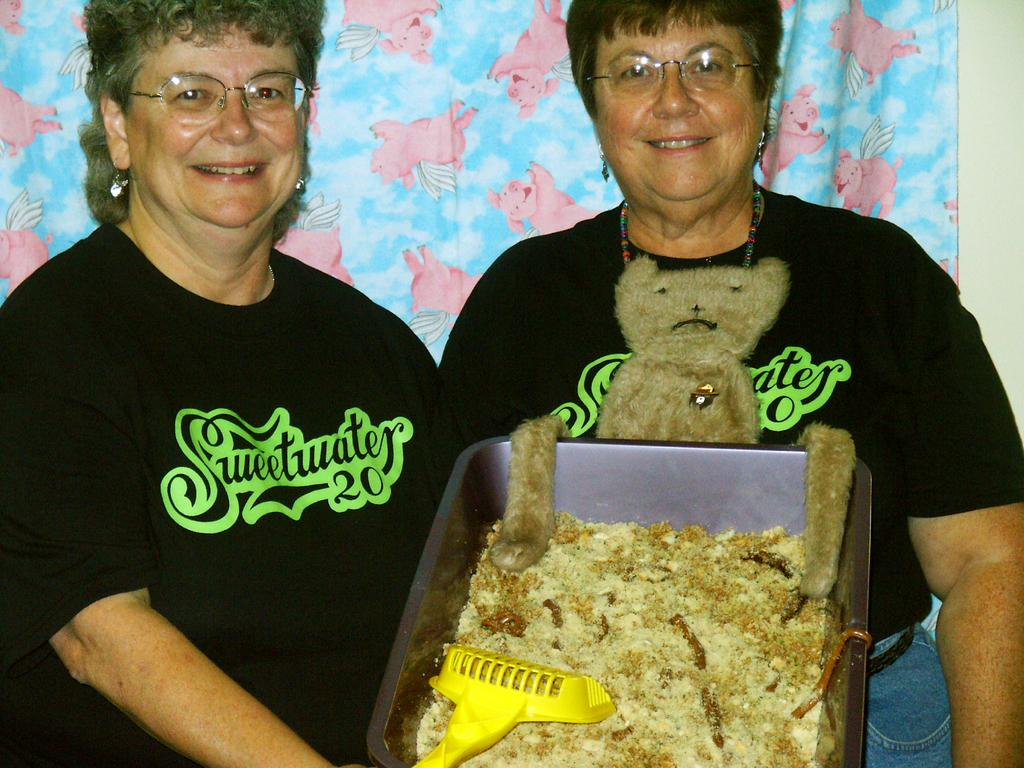How many people are in the image? There are two girls in the image. What is the facial expression of the girls? The girls are smiling. What are the girls holding in the image? The girls are holding a basket. What can be found inside the basket? There is stuff in the basket. What type of potato is being used to power the system in the image? There is no potato or system present in the image; it features two girls holding a basket. Can you tell me how many gloves are visible in the image? There are no gloves visible in the image. 